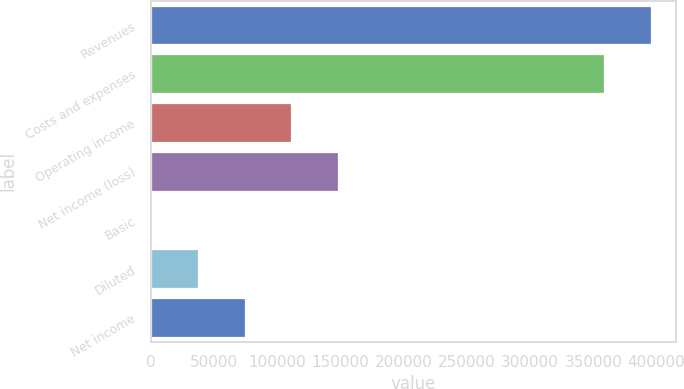Convert chart to OTSL. <chart><loc_0><loc_0><loc_500><loc_500><bar_chart><fcel>Revenues<fcel>Costs and expenses<fcel>Operating income<fcel>Net income (loss)<fcel>Basic<fcel>Diluted<fcel>Net income<nl><fcel>395611<fcel>358600<fcel>111033<fcel>148044<fcel>0.06<fcel>37010.9<fcel>74021.8<nl></chart> 